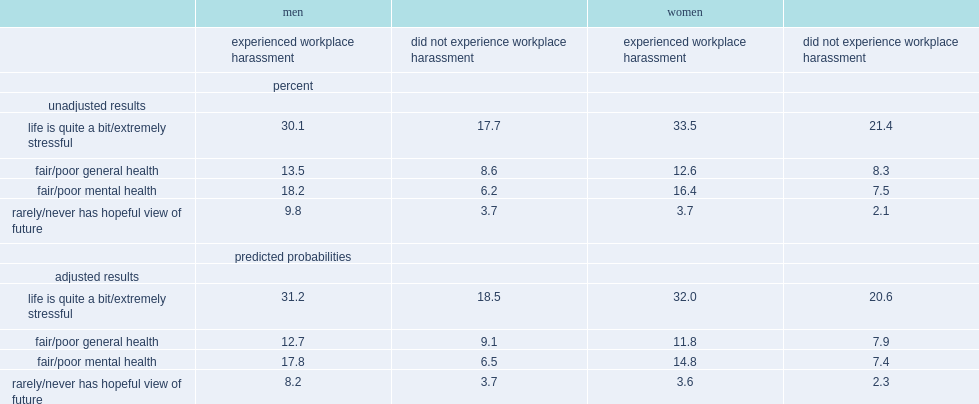Help me parse the entirety of this table. {'header': ['', 'men', '', 'women', ''], 'rows': [['', 'experienced workplace harassment', 'did not experience workplace harassment', 'experienced workplace harassment', 'did not experience workplace harassment'], ['', 'percent', '', '', ''], ['unadjusted results', '', '', '', ''], ['life is quite a bit/extremely stressful', '30.1', '17.7', '33.5', '21.4'], ['fair/poor general health', '13.5', '8.6', '12.6', '8.3'], ['fair/poor mental health', '18.2', '6.2', '16.4', '7.5'], ['rarely/never has hopeful view of future', '9.8', '3.7', '3.7', '2.1'], ['', 'predicted probabilities', '', '', ''], ['adjusted results', '', '', '', ''], ['life is quite a bit/extremely stressful', '31.2', '18.5', '32.0', '20.6'], ['fair/poor general health', '12.7', '9.1', '11.8', '7.9'], ['fair/poor mental health', '17.8', '6.5', '14.8', '7.4'], ['rarely/never has hopeful view of future', '8.2', '3.7', '3.6', '2.3']]} What were the percentages of men who reported experiencing workplace harassment in the past year had poor mental health and those were not harassed respectively? 18.2 6.2. What were the percentages of women who reported experiencing workplace harassment in the past year had poor mental health and those were not harassed respectively? 16.4 7.5. 